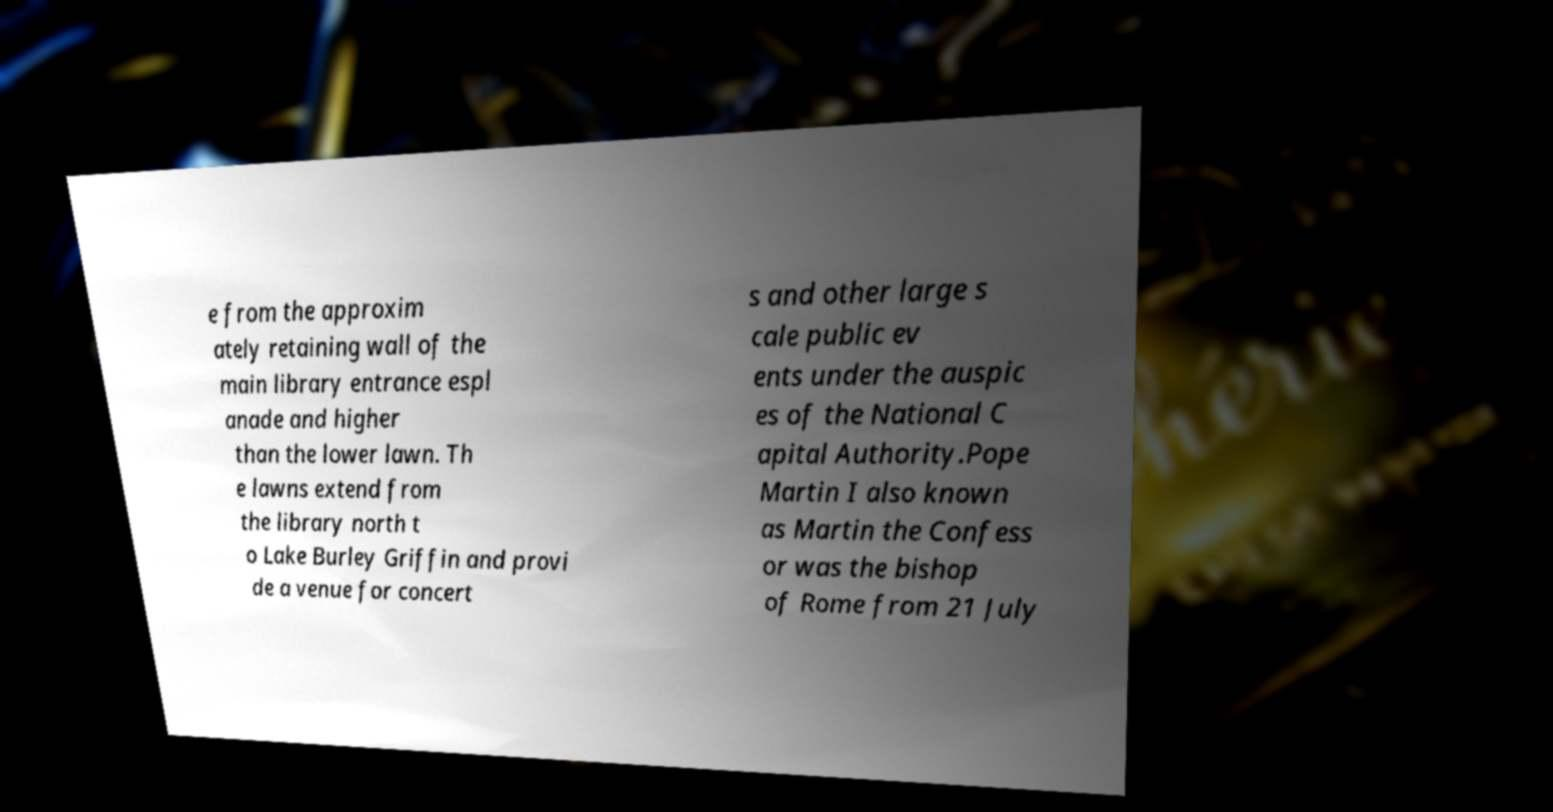Could you assist in decoding the text presented in this image and type it out clearly? e from the approxim ately retaining wall of the main library entrance espl anade and higher than the lower lawn. Th e lawns extend from the library north t o Lake Burley Griffin and provi de a venue for concert s and other large s cale public ev ents under the auspic es of the National C apital Authority.Pope Martin I also known as Martin the Confess or was the bishop of Rome from 21 July 